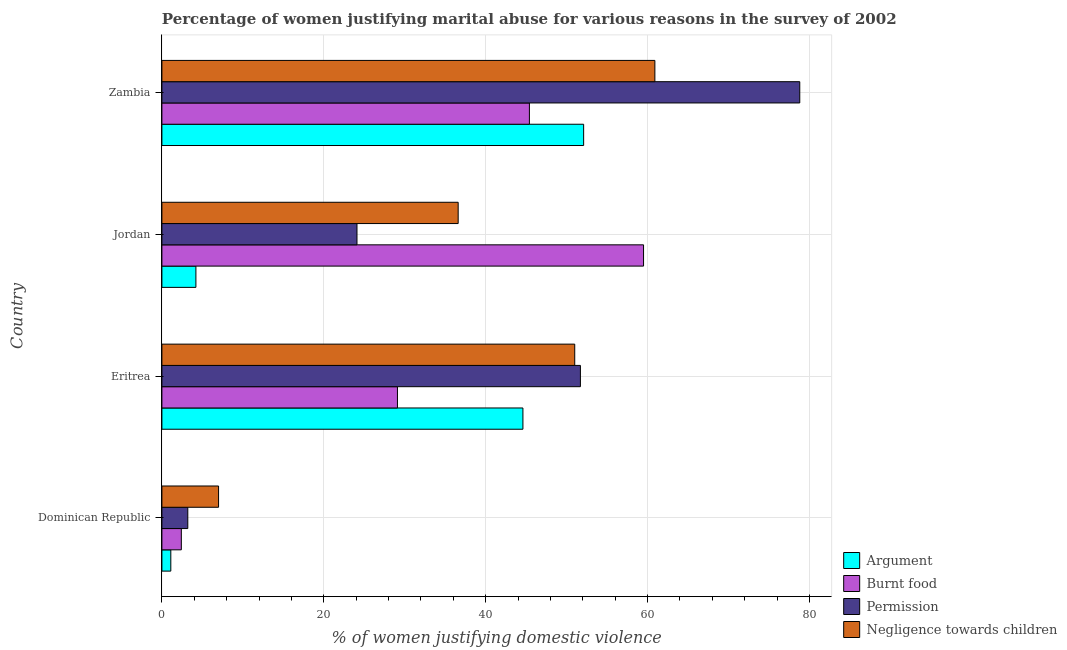How many different coloured bars are there?
Give a very brief answer. 4. How many groups of bars are there?
Offer a very short reply. 4. Are the number of bars per tick equal to the number of legend labels?
Give a very brief answer. Yes. How many bars are there on the 1st tick from the bottom?
Provide a succinct answer. 4. What is the label of the 4th group of bars from the top?
Keep it short and to the point. Dominican Republic. Across all countries, what is the maximum percentage of women justifying abuse for showing negligence towards children?
Make the answer very short. 60.9. In which country was the percentage of women justifying abuse for going without permission maximum?
Make the answer very short. Zambia. In which country was the percentage of women justifying abuse in the case of an argument minimum?
Provide a short and direct response. Dominican Republic. What is the total percentage of women justifying abuse for showing negligence towards children in the graph?
Give a very brief answer. 155.5. What is the difference between the percentage of women justifying abuse for going without permission in Dominican Republic and that in Eritrea?
Ensure brevity in your answer.  -48.5. What is the difference between the percentage of women justifying abuse in the case of an argument in Eritrea and the percentage of women justifying abuse for showing negligence towards children in Jordan?
Offer a terse response. 8. What is the difference between the percentage of women justifying abuse for burning food and percentage of women justifying abuse for going without permission in Zambia?
Give a very brief answer. -33.4. What is the ratio of the percentage of women justifying abuse in the case of an argument in Dominican Republic to that in Zambia?
Offer a very short reply. 0.02. Is the percentage of women justifying abuse for showing negligence towards children in Dominican Republic less than that in Jordan?
Ensure brevity in your answer.  Yes. What is the difference between the highest and the second highest percentage of women justifying abuse for showing negligence towards children?
Make the answer very short. 9.9. What is the difference between the highest and the lowest percentage of women justifying abuse for showing negligence towards children?
Ensure brevity in your answer.  53.9. In how many countries, is the percentage of women justifying abuse for burning food greater than the average percentage of women justifying abuse for burning food taken over all countries?
Keep it short and to the point. 2. Is the sum of the percentage of women justifying abuse in the case of an argument in Dominican Republic and Jordan greater than the maximum percentage of women justifying abuse for showing negligence towards children across all countries?
Your response must be concise. No. What does the 1st bar from the top in Eritrea represents?
Ensure brevity in your answer.  Negligence towards children. What does the 2nd bar from the bottom in Dominican Republic represents?
Your answer should be compact. Burnt food. Is it the case that in every country, the sum of the percentage of women justifying abuse in the case of an argument and percentage of women justifying abuse for burning food is greater than the percentage of women justifying abuse for going without permission?
Provide a short and direct response. Yes. How many bars are there?
Make the answer very short. 16. Are all the bars in the graph horizontal?
Your answer should be very brief. Yes. How many countries are there in the graph?
Offer a very short reply. 4. What is the difference between two consecutive major ticks on the X-axis?
Your response must be concise. 20. Does the graph contain any zero values?
Your response must be concise. No. How are the legend labels stacked?
Your response must be concise. Vertical. What is the title of the graph?
Provide a succinct answer. Percentage of women justifying marital abuse for various reasons in the survey of 2002. Does "Social Awareness" appear as one of the legend labels in the graph?
Keep it short and to the point. No. What is the label or title of the X-axis?
Your answer should be compact. % of women justifying domestic violence. What is the % of women justifying domestic violence of Argument in Eritrea?
Your response must be concise. 44.6. What is the % of women justifying domestic violence in Burnt food in Eritrea?
Keep it short and to the point. 29.1. What is the % of women justifying domestic violence of Permission in Eritrea?
Give a very brief answer. 51.7. What is the % of women justifying domestic violence in Negligence towards children in Eritrea?
Ensure brevity in your answer.  51. What is the % of women justifying domestic violence in Argument in Jordan?
Give a very brief answer. 4.2. What is the % of women justifying domestic violence in Burnt food in Jordan?
Offer a very short reply. 59.5. What is the % of women justifying domestic violence of Permission in Jordan?
Keep it short and to the point. 24.1. What is the % of women justifying domestic violence in Negligence towards children in Jordan?
Make the answer very short. 36.6. What is the % of women justifying domestic violence of Argument in Zambia?
Ensure brevity in your answer.  52.1. What is the % of women justifying domestic violence of Burnt food in Zambia?
Your answer should be compact. 45.4. What is the % of women justifying domestic violence in Permission in Zambia?
Offer a terse response. 78.8. What is the % of women justifying domestic violence of Negligence towards children in Zambia?
Your answer should be compact. 60.9. Across all countries, what is the maximum % of women justifying domestic violence of Argument?
Provide a succinct answer. 52.1. Across all countries, what is the maximum % of women justifying domestic violence of Burnt food?
Your answer should be compact. 59.5. Across all countries, what is the maximum % of women justifying domestic violence in Permission?
Your answer should be compact. 78.8. Across all countries, what is the maximum % of women justifying domestic violence in Negligence towards children?
Provide a succinct answer. 60.9. Across all countries, what is the minimum % of women justifying domestic violence in Argument?
Keep it short and to the point. 1.1. Across all countries, what is the minimum % of women justifying domestic violence of Burnt food?
Make the answer very short. 2.4. What is the total % of women justifying domestic violence of Argument in the graph?
Provide a short and direct response. 102. What is the total % of women justifying domestic violence of Burnt food in the graph?
Ensure brevity in your answer.  136.4. What is the total % of women justifying domestic violence of Permission in the graph?
Offer a terse response. 157.8. What is the total % of women justifying domestic violence of Negligence towards children in the graph?
Make the answer very short. 155.5. What is the difference between the % of women justifying domestic violence in Argument in Dominican Republic and that in Eritrea?
Provide a succinct answer. -43.5. What is the difference between the % of women justifying domestic violence in Burnt food in Dominican Republic and that in Eritrea?
Ensure brevity in your answer.  -26.7. What is the difference between the % of women justifying domestic violence in Permission in Dominican Republic and that in Eritrea?
Your answer should be very brief. -48.5. What is the difference between the % of women justifying domestic violence of Negligence towards children in Dominican Republic and that in Eritrea?
Your answer should be compact. -44. What is the difference between the % of women justifying domestic violence in Burnt food in Dominican Republic and that in Jordan?
Your answer should be very brief. -57.1. What is the difference between the % of women justifying domestic violence in Permission in Dominican Republic and that in Jordan?
Provide a succinct answer. -20.9. What is the difference between the % of women justifying domestic violence of Negligence towards children in Dominican Republic and that in Jordan?
Ensure brevity in your answer.  -29.6. What is the difference between the % of women justifying domestic violence of Argument in Dominican Republic and that in Zambia?
Provide a short and direct response. -51. What is the difference between the % of women justifying domestic violence in Burnt food in Dominican Republic and that in Zambia?
Your answer should be compact. -43. What is the difference between the % of women justifying domestic violence of Permission in Dominican Republic and that in Zambia?
Offer a very short reply. -75.6. What is the difference between the % of women justifying domestic violence in Negligence towards children in Dominican Republic and that in Zambia?
Give a very brief answer. -53.9. What is the difference between the % of women justifying domestic violence of Argument in Eritrea and that in Jordan?
Ensure brevity in your answer.  40.4. What is the difference between the % of women justifying domestic violence in Burnt food in Eritrea and that in Jordan?
Your answer should be compact. -30.4. What is the difference between the % of women justifying domestic violence in Permission in Eritrea and that in Jordan?
Provide a succinct answer. 27.6. What is the difference between the % of women justifying domestic violence in Negligence towards children in Eritrea and that in Jordan?
Your answer should be compact. 14.4. What is the difference between the % of women justifying domestic violence in Burnt food in Eritrea and that in Zambia?
Your answer should be very brief. -16.3. What is the difference between the % of women justifying domestic violence in Permission in Eritrea and that in Zambia?
Offer a very short reply. -27.1. What is the difference between the % of women justifying domestic violence of Negligence towards children in Eritrea and that in Zambia?
Ensure brevity in your answer.  -9.9. What is the difference between the % of women justifying domestic violence in Argument in Jordan and that in Zambia?
Offer a very short reply. -47.9. What is the difference between the % of women justifying domestic violence in Burnt food in Jordan and that in Zambia?
Your response must be concise. 14.1. What is the difference between the % of women justifying domestic violence of Permission in Jordan and that in Zambia?
Your answer should be very brief. -54.7. What is the difference between the % of women justifying domestic violence of Negligence towards children in Jordan and that in Zambia?
Give a very brief answer. -24.3. What is the difference between the % of women justifying domestic violence of Argument in Dominican Republic and the % of women justifying domestic violence of Burnt food in Eritrea?
Keep it short and to the point. -28. What is the difference between the % of women justifying domestic violence of Argument in Dominican Republic and the % of women justifying domestic violence of Permission in Eritrea?
Your response must be concise. -50.6. What is the difference between the % of women justifying domestic violence of Argument in Dominican Republic and the % of women justifying domestic violence of Negligence towards children in Eritrea?
Make the answer very short. -49.9. What is the difference between the % of women justifying domestic violence of Burnt food in Dominican Republic and the % of women justifying domestic violence of Permission in Eritrea?
Provide a succinct answer. -49.3. What is the difference between the % of women justifying domestic violence in Burnt food in Dominican Republic and the % of women justifying domestic violence in Negligence towards children in Eritrea?
Ensure brevity in your answer.  -48.6. What is the difference between the % of women justifying domestic violence in Permission in Dominican Republic and the % of women justifying domestic violence in Negligence towards children in Eritrea?
Keep it short and to the point. -47.8. What is the difference between the % of women justifying domestic violence in Argument in Dominican Republic and the % of women justifying domestic violence in Burnt food in Jordan?
Make the answer very short. -58.4. What is the difference between the % of women justifying domestic violence of Argument in Dominican Republic and the % of women justifying domestic violence of Negligence towards children in Jordan?
Ensure brevity in your answer.  -35.5. What is the difference between the % of women justifying domestic violence in Burnt food in Dominican Republic and the % of women justifying domestic violence in Permission in Jordan?
Your answer should be very brief. -21.7. What is the difference between the % of women justifying domestic violence in Burnt food in Dominican Republic and the % of women justifying domestic violence in Negligence towards children in Jordan?
Provide a succinct answer. -34.2. What is the difference between the % of women justifying domestic violence of Permission in Dominican Republic and the % of women justifying domestic violence of Negligence towards children in Jordan?
Make the answer very short. -33.4. What is the difference between the % of women justifying domestic violence of Argument in Dominican Republic and the % of women justifying domestic violence of Burnt food in Zambia?
Provide a short and direct response. -44.3. What is the difference between the % of women justifying domestic violence in Argument in Dominican Republic and the % of women justifying domestic violence in Permission in Zambia?
Your answer should be compact. -77.7. What is the difference between the % of women justifying domestic violence of Argument in Dominican Republic and the % of women justifying domestic violence of Negligence towards children in Zambia?
Your answer should be compact. -59.8. What is the difference between the % of women justifying domestic violence in Burnt food in Dominican Republic and the % of women justifying domestic violence in Permission in Zambia?
Your response must be concise. -76.4. What is the difference between the % of women justifying domestic violence of Burnt food in Dominican Republic and the % of women justifying domestic violence of Negligence towards children in Zambia?
Keep it short and to the point. -58.5. What is the difference between the % of women justifying domestic violence of Permission in Dominican Republic and the % of women justifying domestic violence of Negligence towards children in Zambia?
Provide a short and direct response. -57.7. What is the difference between the % of women justifying domestic violence in Argument in Eritrea and the % of women justifying domestic violence in Burnt food in Jordan?
Ensure brevity in your answer.  -14.9. What is the difference between the % of women justifying domestic violence in Argument in Eritrea and the % of women justifying domestic violence in Negligence towards children in Jordan?
Your answer should be compact. 8. What is the difference between the % of women justifying domestic violence in Argument in Eritrea and the % of women justifying domestic violence in Burnt food in Zambia?
Your answer should be compact. -0.8. What is the difference between the % of women justifying domestic violence of Argument in Eritrea and the % of women justifying domestic violence of Permission in Zambia?
Your answer should be very brief. -34.2. What is the difference between the % of women justifying domestic violence in Argument in Eritrea and the % of women justifying domestic violence in Negligence towards children in Zambia?
Offer a very short reply. -16.3. What is the difference between the % of women justifying domestic violence of Burnt food in Eritrea and the % of women justifying domestic violence of Permission in Zambia?
Offer a terse response. -49.7. What is the difference between the % of women justifying domestic violence of Burnt food in Eritrea and the % of women justifying domestic violence of Negligence towards children in Zambia?
Offer a terse response. -31.8. What is the difference between the % of women justifying domestic violence in Permission in Eritrea and the % of women justifying domestic violence in Negligence towards children in Zambia?
Your response must be concise. -9.2. What is the difference between the % of women justifying domestic violence in Argument in Jordan and the % of women justifying domestic violence in Burnt food in Zambia?
Make the answer very short. -41.2. What is the difference between the % of women justifying domestic violence of Argument in Jordan and the % of women justifying domestic violence of Permission in Zambia?
Offer a very short reply. -74.6. What is the difference between the % of women justifying domestic violence in Argument in Jordan and the % of women justifying domestic violence in Negligence towards children in Zambia?
Provide a short and direct response. -56.7. What is the difference between the % of women justifying domestic violence of Burnt food in Jordan and the % of women justifying domestic violence of Permission in Zambia?
Your response must be concise. -19.3. What is the difference between the % of women justifying domestic violence in Permission in Jordan and the % of women justifying domestic violence in Negligence towards children in Zambia?
Provide a short and direct response. -36.8. What is the average % of women justifying domestic violence in Argument per country?
Your answer should be very brief. 25.5. What is the average % of women justifying domestic violence of Burnt food per country?
Your answer should be compact. 34.1. What is the average % of women justifying domestic violence in Permission per country?
Provide a short and direct response. 39.45. What is the average % of women justifying domestic violence in Negligence towards children per country?
Provide a succinct answer. 38.88. What is the difference between the % of women justifying domestic violence in Argument and % of women justifying domestic violence in Burnt food in Dominican Republic?
Offer a terse response. -1.3. What is the difference between the % of women justifying domestic violence in Argument and % of women justifying domestic violence in Permission in Dominican Republic?
Ensure brevity in your answer.  -2.1. What is the difference between the % of women justifying domestic violence of Argument and % of women justifying domestic violence of Negligence towards children in Dominican Republic?
Your answer should be compact. -5.9. What is the difference between the % of women justifying domestic violence in Burnt food and % of women justifying domestic violence in Permission in Dominican Republic?
Offer a terse response. -0.8. What is the difference between the % of women justifying domestic violence of Permission and % of women justifying domestic violence of Negligence towards children in Dominican Republic?
Ensure brevity in your answer.  -3.8. What is the difference between the % of women justifying domestic violence of Argument and % of women justifying domestic violence of Burnt food in Eritrea?
Give a very brief answer. 15.5. What is the difference between the % of women justifying domestic violence in Burnt food and % of women justifying domestic violence in Permission in Eritrea?
Make the answer very short. -22.6. What is the difference between the % of women justifying domestic violence of Burnt food and % of women justifying domestic violence of Negligence towards children in Eritrea?
Provide a succinct answer. -21.9. What is the difference between the % of women justifying domestic violence in Permission and % of women justifying domestic violence in Negligence towards children in Eritrea?
Your response must be concise. 0.7. What is the difference between the % of women justifying domestic violence in Argument and % of women justifying domestic violence in Burnt food in Jordan?
Give a very brief answer. -55.3. What is the difference between the % of women justifying domestic violence in Argument and % of women justifying domestic violence in Permission in Jordan?
Provide a succinct answer. -19.9. What is the difference between the % of women justifying domestic violence of Argument and % of women justifying domestic violence of Negligence towards children in Jordan?
Make the answer very short. -32.4. What is the difference between the % of women justifying domestic violence of Burnt food and % of women justifying domestic violence of Permission in Jordan?
Offer a very short reply. 35.4. What is the difference between the % of women justifying domestic violence in Burnt food and % of women justifying domestic violence in Negligence towards children in Jordan?
Give a very brief answer. 22.9. What is the difference between the % of women justifying domestic violence of Argument and % of women justifying domestic violence of Permission in Zambia?
Give a very brief answer. -26.7. What is the difference between the % of women justifying domestic violence in Argument and % of women justifying domestic violence in Negligence towards children in Zambia?
Offer a terse response. -8.8. What is the difference between the % of women justifying domestic violence of Burnt food and % of women justifying domestic violence of Permission in Zambia?
Offer a terse response. -33.4. What is the difference between the % of women justifying domestic violence of Burnt food and % of women justifying domestic violence of Negligence towards children in Zambia?
Keep it short and to the point. -15.5. What is the ratio of the % of women justifying domestic violence in Argument in Dominican Republic to that in Eritrea?
Provide a succinct answer. 0.02. What is the ratio of the % of women justifying domestic violence in Burnt food in Dominican Republic to that in Eritrea?
Offer a terse response. 0.08. What is the ratio of the % of women justifying domestic violence in Permission in Dominican Republic to that in Eritrea?
Ensure brevity in your answer.  0.06. What is the ratio of the % of women justifying domestic violence in Negligence towards children in Dominican Republic to that in Eritrea?
Provide a succinct answer. 0.14. What is the ratio of the % of women justifying domestic violence in Argument in Dominican Republic to that in Jordan?
Provide a succinct answer. 0.26. What is the ratio of the % of women justifying domestic violence of Burnt food in Dominican Republic to that in Jordan?
Offer a terse response. 0.04. What is the ratio of the % of women justifying domestic violence of Permission in Dominican Republic to that in Jordan?
Keep it short and to the point. 0.13. What is the ratio of the % of women justifying domestic violence in Negligence towards children in Dominican Republic to that in Jordan?
Provide a succinct answer. 0.19. What is the ratio of the % of women justifying domestic violence in Argument in Dominican Republic to that in Zambia?
Your answer should be compact. 0.02. What is the ratio of the % of women justifying domestic violence in Burnt food in Dominican Republic to that in Zambia?
Your answer should be compact. 0.05. What is the ratio of the % of women justifying domestic violence of Permission in Dominican Republic to that in Zambia?
Your response must be concise. 0.04. What is the ratio of the % of women justifying domestic violence in Negligence towards children in Dominican Republic to that in Zambia?
Provide a succinct answer. 0.11. What is the ratio of the % of women justifying domestic violence in Argument in Eritrea to that in Jordan?
Provide a short and direct response. 10.62. What is the ratio of the % of women justifying domestic violence of Burnt food in Eritrea to that in Jordan?
Ensure brevity in your answer.  0.49. What is the ratio of the % of women justifying domestic violence of Permission in Eritrea to that in Jordan?
Offer a very short reply. 2.15. What is the ratio of the % of women justifying domestic violence in Negligence towards children in Eritrea to that in Jordan?
Provide a succinct answer. 1.39. What is the ratio of the % of women justifying domestic violence of Argument in Eritrea to that in Zambia?
Provide a short and direct response. 0.86. What is the ratio of the % of women justifying domestic violence of Burnt food in Eritrea to that in Zambia?
Give a very brief answer. 0.64. What is the ratio of the % of women justifying domestic violence in Permission in Eritrea to that in Zambia?
Keep it short and to the point. 0.66. What is the ratio of the % of women justifying domestic violence in Negligence towards children in Eritrea to that in Zambia?
Offer a terse response. 0.84. What is the ratio of the % of women justifying domestic violence in Argument in Jordan to that in Zambia?
Your answer should be compact. 0.08. What is the ratio of the % of women justifying domestic violence of Burnt food in Jordan to that in Zambia?
Keep it short and to the point. 1.31. What is the ratio of the % of women justifying domestic violence in Permission in Jordan to that in Zambia?
Offer a terse response. 0.31. What is the ratio of the % of women justifying domestic violence in Negligence towards children in Jordan to that in Zambia?
Keep it short and to the point. 0.6. What is the difference between the highest and the second highest % of women justifying domestic violence of Argument?
Your answer should be compact. 7.5. What is the difference between the highest and the second highest % of women justifying domestic violence of Permission?
Your answer should be very brief. 27.1. What is the difference between the highest and the lowest % of women justifying domestic violence in Burnt food?
Offer a very short reply. 57.1. What is the difference between the highest and the lowest % of women justifying domestic violence of Permission?
Give a very brief answer. 75.6. What is the difference between the highest and the lowest % of women justifying domestic violence of Negligence towards children?
Your answer should be very brief. 53.9. 